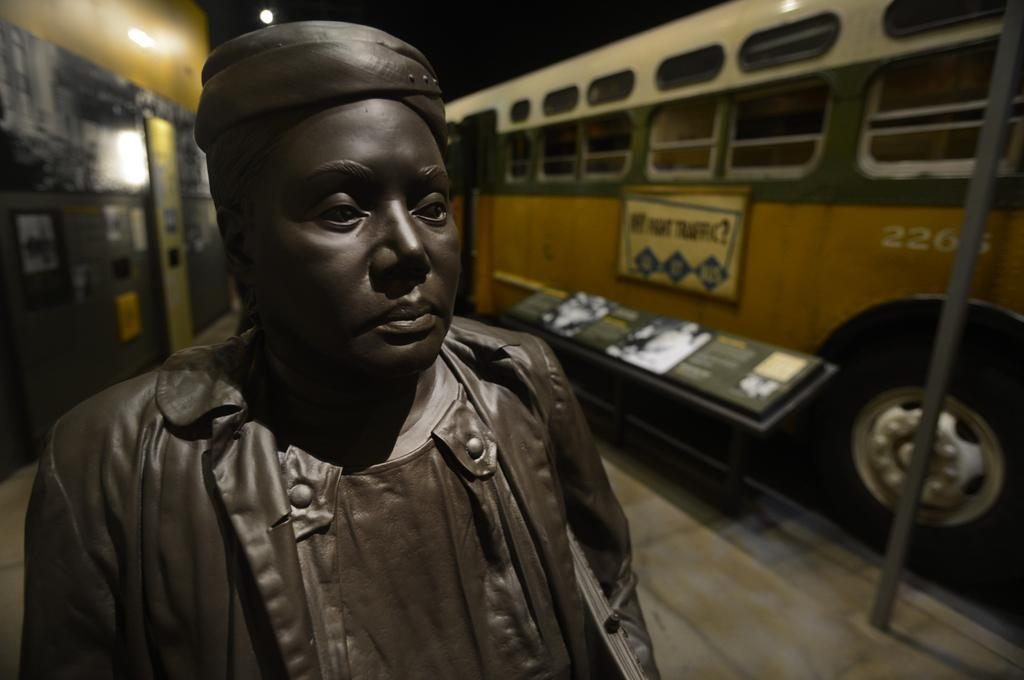What is the main subject of the image? There is a statue of a woman in the image. What can be seen in the background of the image? There is a motor vehicle, a pole, and information boards in the background of the image. What type of fiction is the woman reading in the image? There is no indication that the woman is reading any fiction in the image, as she is a statue. What can be learned from the information boards in the image? The content of the information boards cannot be determined from the image, as they are not legible. 